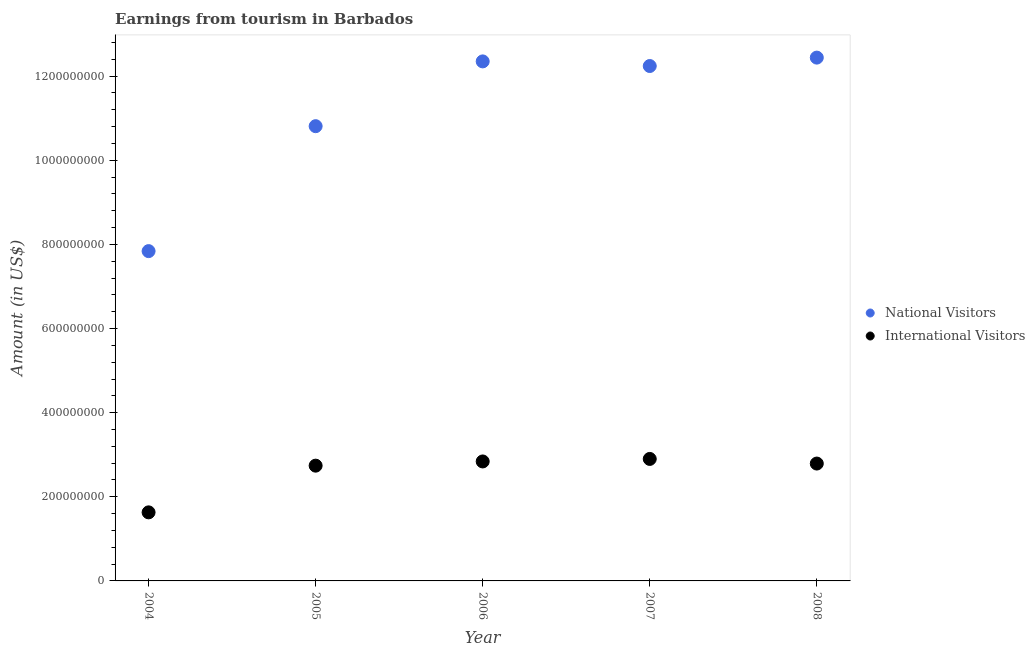How many different coloured dotlines are there?
Ensure brevity in your answer.  2. What is the amount earned from international visitors in 2004?
Provide a short and direct response. 1.63e+08. Across all years, what is the maximum amount earned from international visitors?
Give a very brief answer. 2.90e+08. Across all years, what is the minimum amount earned from national visitors?
Provide a succinct answer. 7.84e+08. In which year was the amount earned from national visitors maximum?
Keep it short and to the point. 2008. In which year was the amount earned from national visitors minimum?
Offer a very short reply. 2004. What is the total amount earned from international visitors in the graph?
Ensure brevity in your answer.  1.29e+09. What is the difference between the amount earned from national visitors in 2004 and that in 2008?
Ensure brevity in your answer.  -4.60e+08. What is the difference between the amount earned from international visitors in 2007 and the amount earned from national visitors in 2006?
Provide a short and direct response. -9.45e+08. What is the average amount earned from international visitors per year?
Give a very brief answer. 2.58e+08. In the year 2006, what is the difference between the amount earned from national visitors and amount earned from international visitors?
Offer a terse response. 9.51e+08. In how many years, is the amount earned from international visitors greater than 760000000 US$?
Provide a short and direct response. 0. What is the ratio of the amount earned from national visitors in 2004 to that in 2007?
Keep it short and to the point. 0.64. Is the amount earned from national visitors in 2004 less than that in 2007?
Provide a short and direct response. Yes. Is the difference between the amount earned from national visitors in 2005 and 2008 greater than the difference between the amount earned from international visitors in 2005 and 2008?
Make the answer very short. No. What is the difference between the highest and the second highest amount earned from national visitors?
Offer a terse response. 9.00e+06. What is the difference between the highest and the lowest amount earned from international visitors?
Provide a short and direct response. 1.27e+08. In how many years, is the amount earned from international visitors greater than the average amount earned from international visitors taken over all years?
Provide a succinct answer. 4. Is the sum of the amount earned from international visitors in 2004 and 2005 greater than the maximum amount earned from national visitors across all years?
Keep it short and to the point. No. Is the amount earned from national visitors strictly greater than the amount earned from international visitors over the years?
Provide a succinct answer. Yes. Is the amount earned from international visitors strictly less than the amount earned from national visitors over the years?
Keep it short and to the point. Yes. How many years are there in the graph?
Offer a terse response. 5. What is the difference between two consecutive major ticks on the Y-axis?
Provide a succinct answer. 2.00e+08. How many legend labels are there?
Give a very brief answer. 2. How are the legend labels stacked?
Offer a terse response. Vertical. What is the title of the graph?
Ensure brevity in your answer.  Earnings from tourism in Barbados. Does "Secondary education" appear as one of the legend labels in the graph?
Your answer should be compact. No. What is the label or title of the X-axis?
Keep it short and to the point. Year. What is the label or title of the Y-axis?
Make the answer very short. Amount (in US$). What is the Amount (in US$) of National Visitors in 2004?
Offer a very short reply. 7.84e+08. What is the Amount (in US$) of International Visitors in 2004?
Offer a very short reply. 1.63e+08. What is the Amount (in US$) in National Visitors in 2005?
Your answer should be very brief. 1.08e+09. What is the Amount (in US$) of International Visitors in 2005?
Provide a short and direct response. 2.74e+08. What is the Amount (in US$) of National Visitors in 2006?
Your answer should be very brief. 1.24e+09. What is the Amount (in US$) in International Visitors in 2006?
Provide a short and direct response. 2.84e+08. What is the Amount (in US$) in National Visitors in 2007?
Make the answer very short. 1.22e+09. What is the Amount (in US$) in International Visitors in 2007?
Your answer should be compact. 2.90e+08. What is the Amount (in US$) of National Visitors in 2008?
Offer a very short reply. 1.24e+09. What is the Amount (in US$) in International Visitors in 2008?
Your answer should be compact. 2.79e+08. Across all years, what is the maximum Amount (in US$) of National Visitors?
Make the answer very short. 1.24e+09. Across all years, what is the maximum Amount (in US$) in International Visitors?
Your response must be concise. 2.90e+08. Across all years, what is the minimum Amount (in US$) of National Visitors?
Your response must be concise. 7.84e+08. Across all years, what is the minimum Amount (in US$) in International Visitors?
Your response must be concise. 1.63e+08. What is the total Amount (in US$) in National Visitors in the graph?
Your answer should be very brief. 5.57e+09. What is the total Amount (in US$) of International Visitors in the graph?
Keep it short and to the point. 1.29e+09. What is the difference between the Amount (in US$) of National Visitors in 2004 and that in 2005?
Offer a terse response. -2.97e+08. What is the difference between the Amount (in US$) in International Visitors in 2004 and that in 2005?
Your response must be concise. -1.11e+08. What is the difference between the Amount (in US$) in National Visitors in 2004 and that in 2006?
Offer a very short reply. -4.51e+08. What is the difference between the Amount (in US$) of International Visitors in 2004 and that in 2006?
Your answer should be very brief. -1.21e+08. What is the difference between the Amount (in US$) in National Visitors in 2004 and that in 2007?
Offer a very short reply. -4.40e+08. What is the difference between the Amount (in US$) in International Visitors in 2004 and that in 2007?
Offer a terse response. -1.27e+08. What is the difference between the Amount (in US$) in National Visitors in 2004 and that in 2008?
Offer a terse response. -4.60e+08. What is the difference between the Amount (in US$) in International Visitors in 2004 and that in 2008?
Give a very brief answer. -1.16e+08. What is the difference between the Amount (in US$) of National Visitors in 2005 and that in 2006?
Provide a succinct answer. -1.54e+08. What is the difference between the Amount (in US$) of International Visitors in 2005 and that in 2006?
Keep it short and to the point. -1.00e+07. What is the difference between the Amount (in US$) in National Visitors in 2005 and that in 2007?
Make the answer very short. -1.43e+08. What is the difference between the Amount (in US$) of International Visitors in 2005 and that in 2007?
Provide a short and direct response. -1.60e+07. What is the difference between the Amount (in US$) in National Visitors in 2005 and that in 2008?
Offer a very short reply. -1.63e+08. What is the difference between the Amount (in US$) of International Visitors in 2005 and that in 2008?
Provide a succinct answer. -5.00e+06. What is the difference between the Amount (in US$) of National Visitors in 2006 and that in 2007?
Provide a succinct answer. 1.10e+07. What is the difference between the Amount (in US$) in International Visitors in 2006 and that in 2007?
Provide a short and direct response. -6.00e+06. What is the difference between the Amount (in US$) of National Visitors in 2006 and that in 2008?
Your answer should be compact. -9.00e+06. What is the difference between the Amount (in US$) of International Visitors in 2006 and that in 2008?
Give a very brief answer. 5.00e+06. What is the difference between the Amount (in US$) in National Visitors in 2007 and that in 2008?
Offer a terse response. -2.00e+07. What is the difference between the Amount (in US$) of International Visitors in 2007 and that in 2008?
Offer a very short reply. 1.10e+07. What is the difference between the Amount (in US$) in National Visitors in 2004 and the Amount (in US$) in International Visitors in 2005?
Offer a terse response. 5.10e+08. What is the difference between the Amount (in US$) in National Visitors in 2004 and the Amount (in US$) in International Visitors in 2006?
Keep it short and to the point. 5.00e+08. What is the difference between the Amount (in US$) in National Visitors in 2004 and the Amount (in US$) in International Visitors in 2007?
Your answer should be compact. 4.94e+08. What is the difference between the Amount (in US$) of National Visitors in 2004 and the Amount (in US$) of International Visitors in 2008?
Your answer should be very brief. 5.05e+08. What is the difference between the Amount (in US$) of National Visitors in 2005 and the Amount (in US$) of International Visitors in 2006?
Your answer should be compact. 7.97e+08. What is the difference between the Amount (in US$) in National Visitors in 2005 and the Amount (in US$) in International Visitors in 2007?
Make the answer very short. 7.91e+08. What is the difference between the Amount (in US$) of National Visitors in 2005 and the Amount (in US$) of International Visitors in 2008?
Your answer should be very brief. 8.02e+08. What is the difference between the Amount (in US$) of National Visitors in 2006 and the Amount (in US$) of International Visitors in 2007?
Your answer should be very brief. 9.45e+08. What is the difference between the Amount (in US$) of National Visitors in 2006 and the Amount (in US$) of International Visitors in 2008?
Your answer should be very brief. 9.56e+08. What is the difference between the Amount (in US$) in National Visitors in 2007 and the Amount (in US$) in International Visitors in 2008?
Your answer should be very brief. 9.45e+08. What is the average Amount (in US$) in National Visitors per year?
Provide a short and direct response. 1.11e+09. What is the average Amount (in US$) in International Visitors per year?
Make the answer very short. 2.58e+08. In the year 2004, what is the difference between the Amount (in US$) in National Visitors and Amount (in US$) in International Visitors?
Ensure brevity in your answer.  6.21e+08. In the year 2005, what is the difference between the Amount (in US$) of National Visitors and Amount (in US$) of International Visitors?
Provide a short and direct response. 8.07e+08. In the year 2006, what is the difference between the Amount (in US$) of National Visitors and Amount (in US$) of International Visitors?
Give a very brief answer. 9.51e+08. In the year 2007, what is the difference between the Amount (in US$) in National Visitors and Amount (in US$) in International Visitors?
Your answer should be compact. 9.34e+08. In the year 2008, what is the difference between the Amount (in US$) in National Visitors and Amount (in US$) in International Visitors?
Keep it short and to the point. 9.65e+08. What is the ratio of the Amount (in US$) in National Visitors in 2004 to that in 2005?
Offer a very short reply. 0.73. What is the ratio of the Amount (in US$) in International Visitors in 2004 to that in 2005?
Ensure brevity in your answer.  0.59. What is the ratio of the Amount (in US$) in National Visitors in 2004 to that in 2006?
Your answer should be very brief. 0.63. What is the ratio of the Amount (in US$) in International Visitors in 2004 to that in 2006?
Offer a very short reply. 0.57. What is the ratio of the Amount (in US$) in National Visitors in 2004 to that in 2007?
Your answer should be compact. 0.64. What is the ratio of the Amount (in US$) in International Visitors in 2004 to that in 2007?
Your response must be concise. 0.56. What is the ratio of the Amount (in US$) in National Visitors in 2004 to that in 2008?
Your response must be concise. 0.63. What is the ratio of the Amount (in US$) of International Visitors in 2004 to that in 2008?
Provide a short and direct response. 0.58. What is the ratio of the Amount (in US$) of National Visitors in 2005 to that in 2006?
Offer a terse response. 0.88. What is the ratio of the Amount (in US$) in International Visitors in 2005 to that in 2006?
Your response must be concise. 0.96. What is the ratio of the Amount (in US$) of National Visitors in 2005 to that in 2007?
Your answer should be very brief. 0.88. What is the ratio of the Amount (in US$) of International Visitors in 2005 to that in 2007?
Your answer should be very brief. 0.94. What is the ratio of the Amount (in US$) of National Visitors in 2005 to that in 2008?
Keep it short and to the point. 0.87. What is the ratio of the Amount (in US$) of International Visitors in 2005 to that in 2008?
Provide a short and direct response. 0.98. What is the ratio of the Amount (in US$) of National Visitors in 2006 to that in 2007?
Offer a terse response. 1.01. What is the ratio of the Amount (in US$) of International Visitors in 2006 to that in 2007?
Provide a succinct answer. 0.98. What is the ratio of the Amount (in US$) in National Visitors in 2006 to that in 2008?
Make the answer very short. 0.99. What is the ratio of the Amount (in US$) in International Visitors in 2006 to that in 2008?
Your answer should be compact. 1.02. What is the ratio of the Amount (in US$) of National Visitors in 2007 to that in 2008?
Your response must be concise. 0.98. What is the ratio of the Amount (in US$) of International Visitors in 2007 to that in 2008?
Keep it short and to the point. 1.04. What is the difference between the highest and the second highest Amount (in US$) in National Visitors?
Your answer should be very brief. 9.00e+06. What is the difference between the highest and the lowest Amount (in US$) in National Visitors?
Offer a very short reply. 4.60e+08. What is the difference between the highest and the lowest Amount (in US$) of International Visitors?
Give a very brief answer. 1.27e+08. 